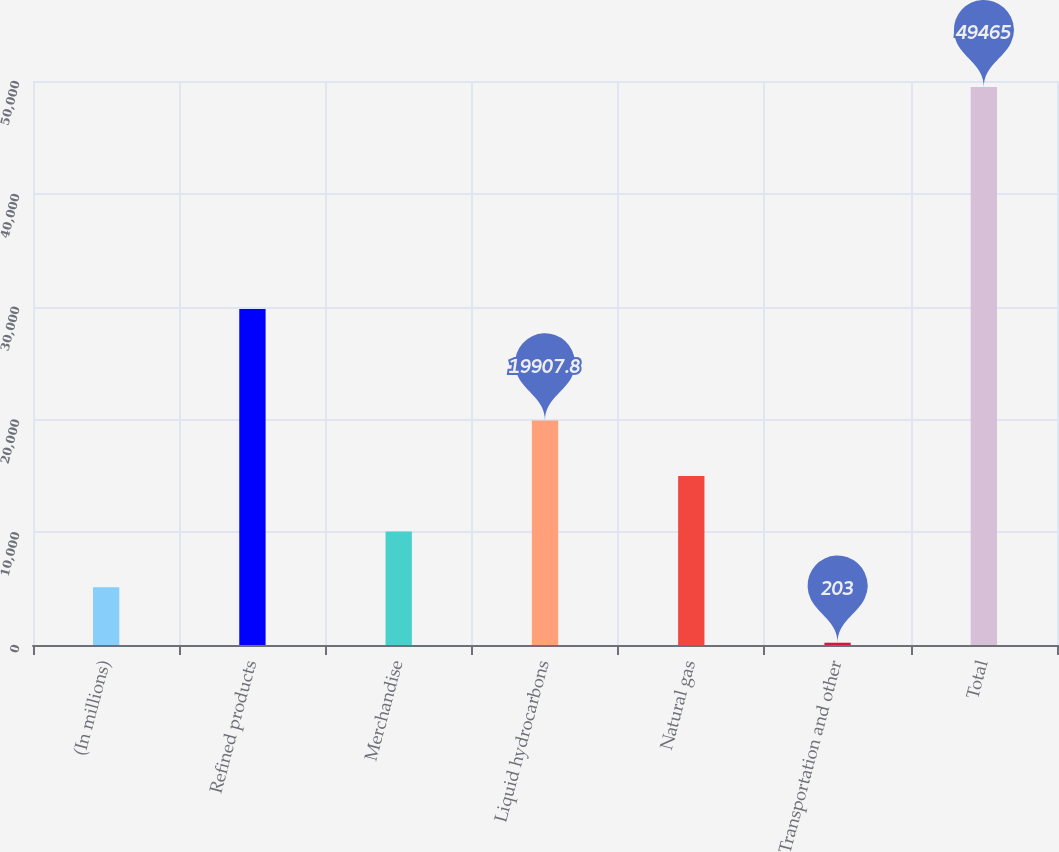Convert chart to OTSL. <chart><loc_0><loc_0><loc_500><loc_500><bar_chart><fcel>(In millions)<fcel>Refined products<fcel>Merchandise<fcel>Liquid hydrocarbons<fcel>Natural gas<fcel>Transportation and other<fcel>Total<nl><fcel>5129.2<fcel>29780<fcel>10055.4<fcel>19907.8<fcel>14981.6<fcel>203<fcel>49465<nl></chart> 